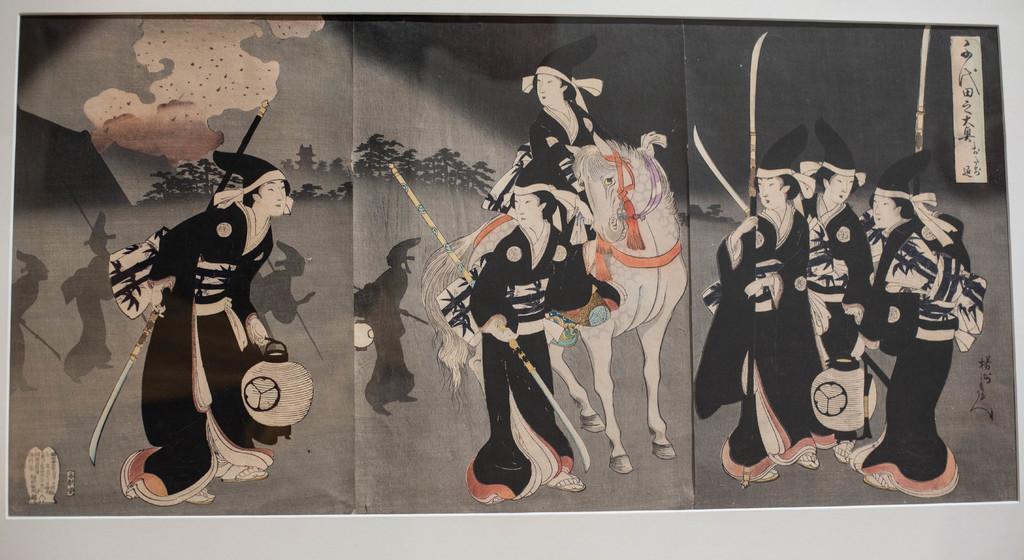Could you give a brief overview of what you see in this image? This is a painted image, in the image there are few people, a horse, few trees, sky and some text. 